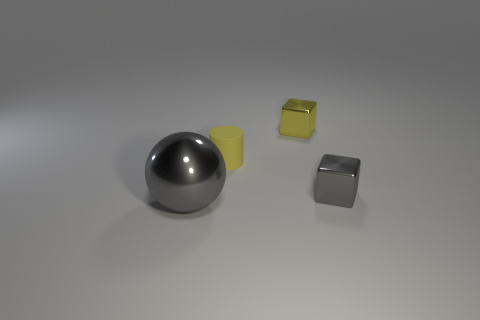Add 3 large gray spheres. How many objects exist? 7 Subtract 0 red cylinders. How many objects are left? 4 Subtract all balls. How many objects are left? 3 Subtract all small rubber cylinders. Subtract all metallic objects. How many objects are left? 0 Add 1 matte cylinders. How many matte cylinders are left? 2 Add 3 small purple things. How many small purple things exist? 3 